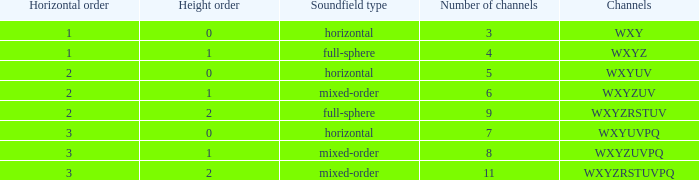If the channels is wxyzuv, what is the number of channels? 6.0. 